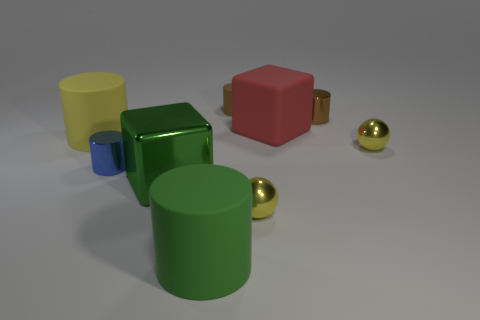There is another object that is the same shape as the red object; what color is it?
Provide a short and direct response. Green. Is there anything else that is the same shape as the blue thing?
Make the answer very short. Yes. There is a big object that is to the left of the large green metallic block; is its shape the same as the rubber object in front of the tiny blue metal object?
Offer a very short reply. Yes. Is the size of the green metal block the same as the rubber cylinder behind the red matte thing?
Provide a succinct answer. No. Is the number of large cyan matte objects greater than the number of large rubber cubes?
Provide a succinct answer. No. Is the material of the ball in front of the blue metal cylinder the same as the tiny brown cylinder that is left of the big matte block?
Your answer should be compact. No. What is the green cylinder made of?
Keep it short and to the point. Rubber. Is the number of green rubber cylinders on the right side of the brown matte cylinder greater than the number of metal things?
Offer a very short reply. No. There is a yellow metal thing that is in front of the small yellow sphere that is behind the small blue metallic object; how many tiny rubber cylinders are in front of it?
Ensure brevity in your answer.  0. The large object that is both behind the big green cube and to the left of the small matte cylinder is made of what material?
Your response must be concise. Rubber. 